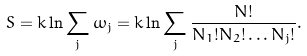<formula> <loc_0><loc_0><loc_500><loc_500>S = k \ln \sum _ { j } \omega _ { j } = k \ln \sum _ { j } \frac { N ! } { N _ { 1 } ! N _ { 2 } ! \dots N _ { j } ! } .</formula> 